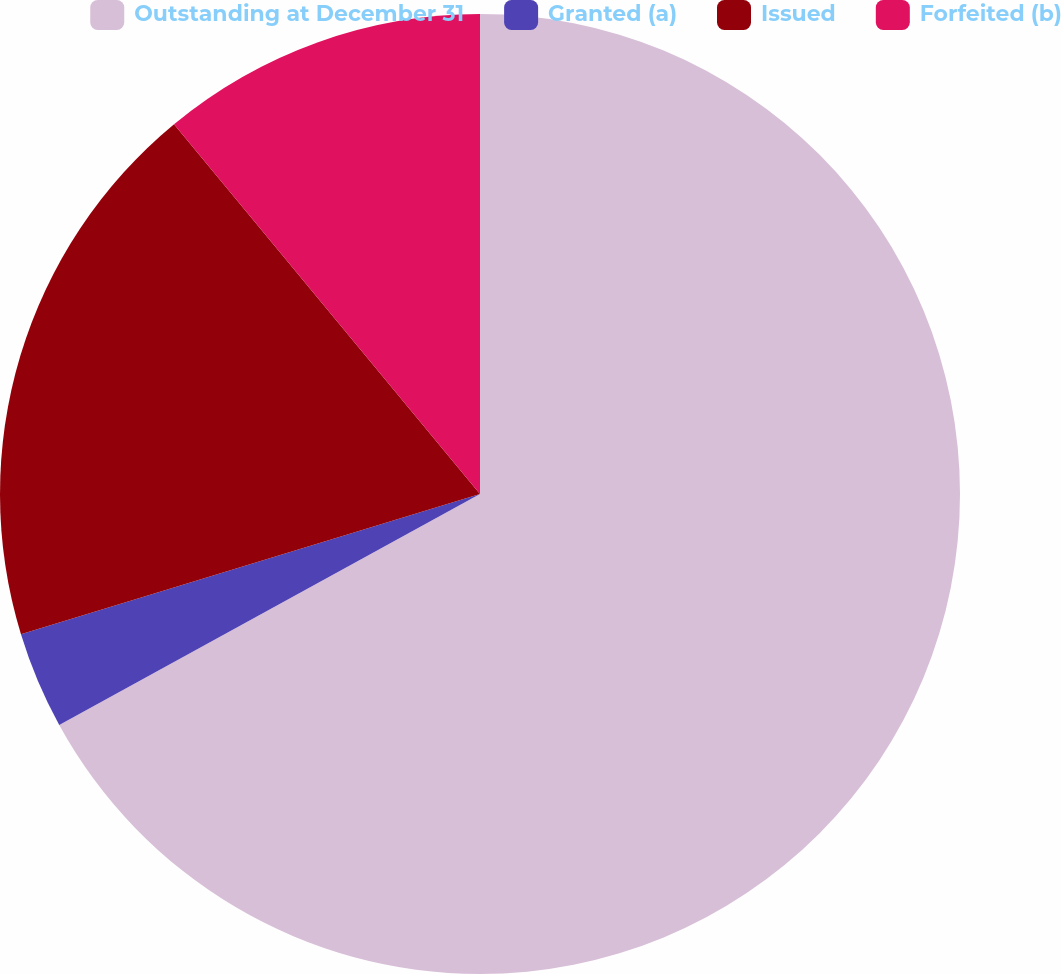Convert chart to OTSL. <chart><loc_0><loc_0><loc_500><loc_500><pie_chart><fcel>Outstanding at December 31<fcel>Granted (a)<fcel>Issued<fcel>Forfeited (b)<nl><fcel>67.01%<fcel>3.27%<fcel>18.72%<fcel>11.0%<nl></chart> 